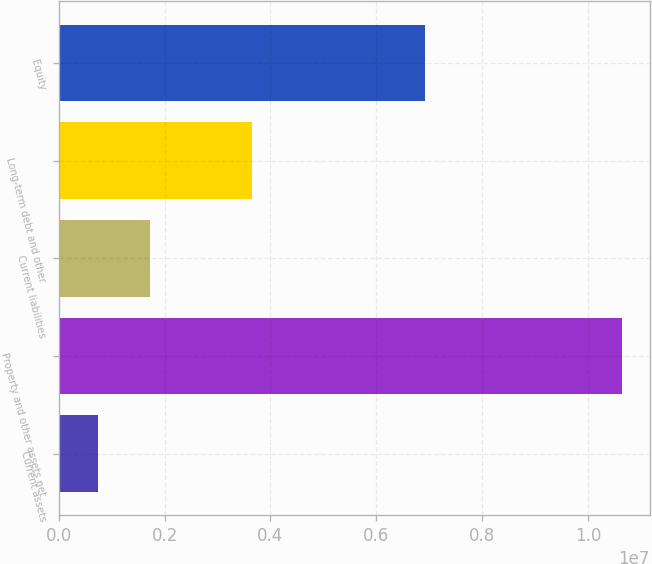<chart> <loc_0><loc_0><loc_500><loc_500><bar_chart><fcel>Current assets<fcel>Property and other assets net<fcel>Current liabilities<fcel>Long-term debt and other<fcel>Equity<nl><fcel>731381<fcel>1.06347e+07<fcel>1.72171e+06<fcel>3.64576e+06<fcel>6.92068e+06<nl></chart> 